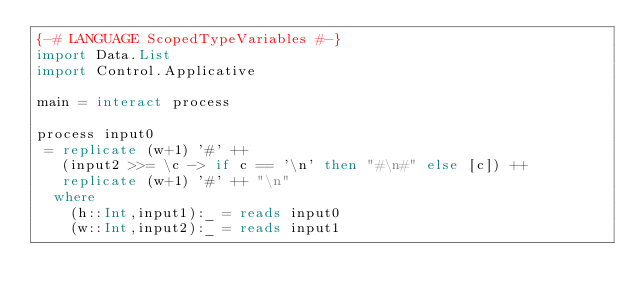Convert code to text. <code><loc_0><loc_0><loc_500><loc_500><_Haskell_>{-# LANGUAGE ScopedTypeVariables #-}
import Data.List
import Control.Applicative

main = interact process

process input0
 = replicate (w+1) '#' ++
   (input2 >>= \c -> if c == '\n' then "#\n#" else [c]) ++
   replicate (w+1) '#' ++ "\n"
  where
    (h::Int,input1):_ = reads input0
    (w::Int,input2):_ = reads input1</code> 